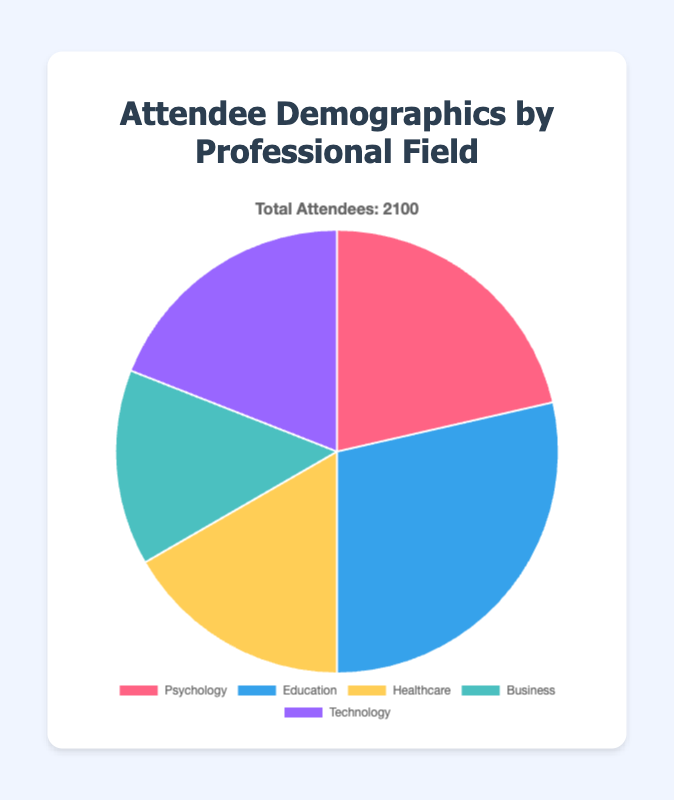What is the percentage of attendees from the Education field? To find the percentage, divide the number of attendees from the Education field (600) by the total number of attendees (2100) and multiply by 100. This is calculated as \( (600 / 2100) * 100 \approx 28.57\% \).
Answer: 28.57% Which professional field has the least number of attendees? The field with the least number of attendees can be identified by looking at the numerical values. Business has 300 attendees, which is the lowest among the fields listed.
Answer: Business Are there more attendees in Technology or Healthcare fields? By comparing the number of attendees: Technology has 400 attendees and Healthcare has 350 attendees. Thus, there are more attendees in Technology.
Answer: Technology What is the difference in the number of attendees between the Business and Psychology fields? Subtract the number of attendees in the Business field (300) from the number in the Psychology field (450). This is \( 450 - 300 = 150 \).
Answer: 150 Which two fields collectively represent the highest number of attendees? Adding the attendees from each field and checking combinations, Education (600) and Psychology (450) together have 1050 attendees, which is the highest combined total.
Answer: Education and Psychology What is the combined percentage representation of the Business and Technology fields? Add the number of attendees from Business (300) and Technology (400). Divide the sum by the total number of attendees (2100) and multiply by 100. This is \( \left( \frac{700}{2100} \right) * 100 \approx 33.33\% \).
Answer: 33.33% How does the number of attendees from Healthcare compare to the median number of attendees across all fields? Arrange the number of attendees in each field in ascending order: 300, 350, 400, 450, 600. The median value is the middle one, which is 400. The Healthcare field has 350 attendees, which is less than the median.
Answer: Less than Which slice of the pie chart is represented in red color? According to the data provided, the Psychology field is represented in red color.
Answer: Psychology What fraction of the total attendees are from Psychology and Education combined? Add the number of attendees from Psychology (450) and Education (600). The sum is 1050. The fraction is \( \frac{1050}{2100} = \frac{1}{2} \).
Answer: 1/2 What is the ratio of attendees from the Technology field to those from the Business field? Divide the number of attendees from Technology (400) by the number from Business (300). The ratio is \( \frac{400}{300} \) which simplifies to \( \frac{4}{3} \).
Answer: 4:3 